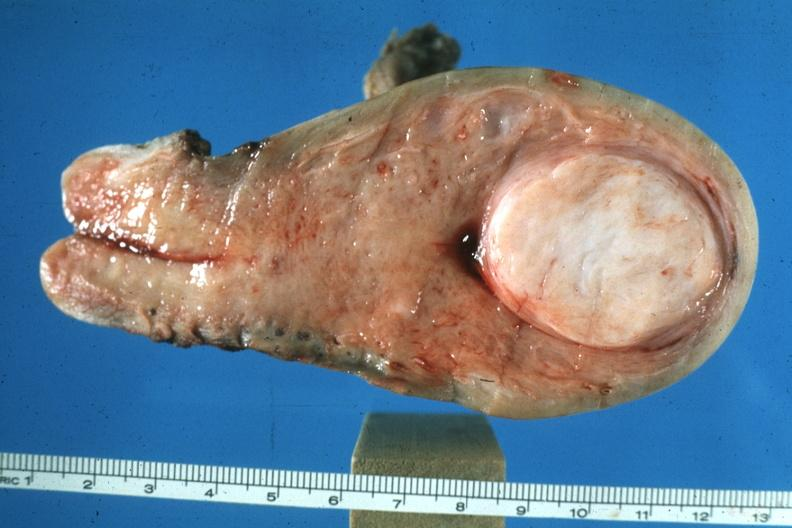where does this belong to?
Answer the question using a single word or phrase. Female reproductive system 